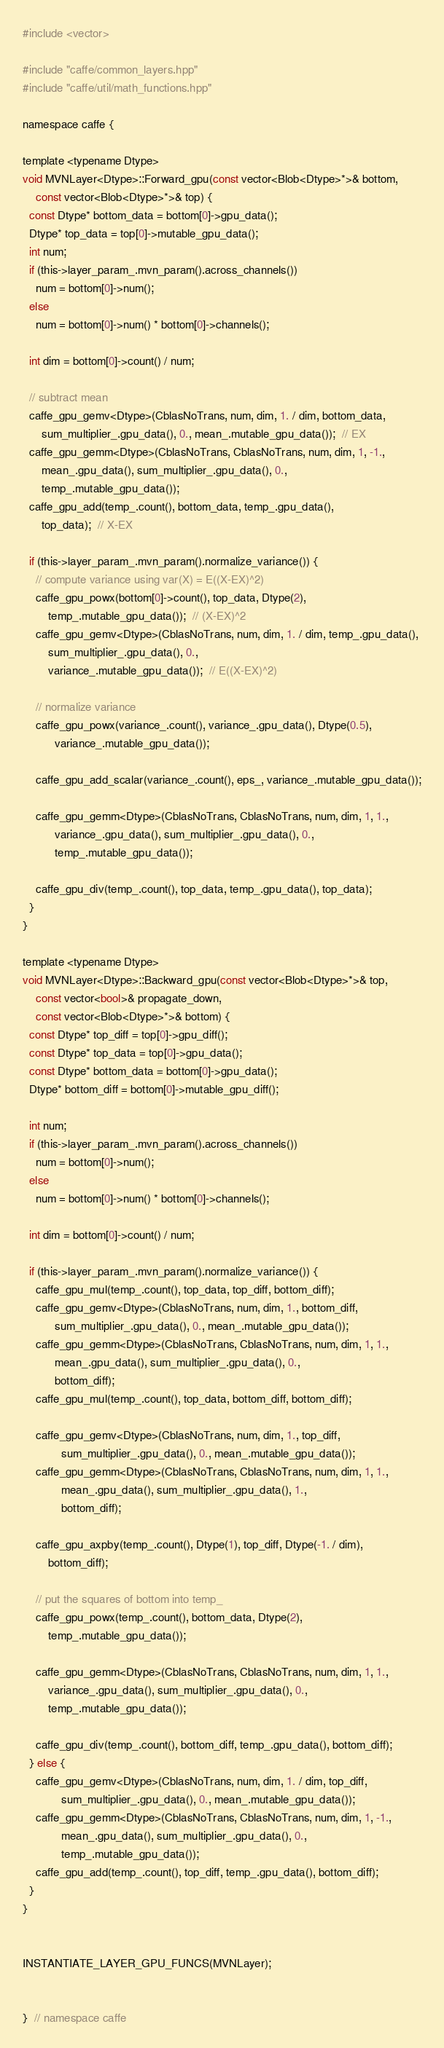Convert code to text. <code><loc_0><loc_0><loc_500><loc_500><_Cuda_>#include <vector>

#include "caffe/common_layers.hpp"
#include "caffe/util/math_functions.hpp"

namespace caffe {

template <typename Dtype>
void MVNLayer<Dtype>::Forward_gpu(const vector<Blob<Dtype>*>& bottom,
    const vector<Blob<Dtype>*>& top) {
  const Dtype* bottom_data = bottom[0]->gpu_data();
  Dtype* top_data = top[0]->mutable_gpu_data();
  int num;
  if (this->layer_param_.mvn_param().across_channels())
    num = bottom[0]->num();
  else
    num = bottom[0]->num() * bottom[0]->channels();

  int dim = bottom[0]->count() / num;

  // subtract mean
  caffe_gpu_gemv<Dtype>(CblasNoTrans, num, dim, 1. / dim, bottom_data,
      sum_multiplier_.gpu_data(), 0., mean_.mutable_gpu_data());  // EX
  caffe_gpu_gemm<Dtype>(CblasNoTrans, CblasNoTrans, num, dim, 1, -1.,
      mean_.gpu_data(), sum_multiplier_.gpu_data(), 0.,
      temp_.mutable_gpu_data());
  caffe_gpu_add(temp_.count(), bottom_data, temp_.gpu_data(),
      top_data);  // X-EX

  if (this->layer_param_.mvn_param().normalize_variance()) {
    // compute variance using var(X) = E((X-EX)^2)
    caffe_gpu_powx(bottom[0]->count(), top_data, Dtype(2),
        temp_.mutable_gpu_data());  // (X-EX)^2
    caffe_gpu_gemv<Dtype>(CblasNoTrans, num, dim, 1. / dim, temp_.gpu_data(),
        sum_multiplier_.gpu_data(), 0.,
        variance_.mutable_gpu_data());  // E((X-EX)^2)

    // normalize variance
    caffe_gpu_powx(variance_.count(), variance_.gpu_data(), Dtype(0.5),
          variance_.mutable_gpu_data());

    caffe_gpu_add_scalar(variance_.count(), eps_, variance_.mutable_gpu_data());

    caffe_gpu_gemm<Dtype>(CblasNoTrans, CblasNoTrans, num, dim, 1, 1.,
          variance_.gpu_data(), sum_multiplier_.gpu_data(), 0.,
          temp_.mutable_gpu_data());

    caffe_gpu_div(temp_.count(), top_data, temp_.gpu_data(), top_data);
  }
}

template <typename Dtype>
void MVNLayer<Dtype>::Backward_gpu(const vector<Blob<Dtype>*>& top,
    const vector<bool>& propagate_down,
    const vector<Blob<Dtype>*>& bottom) {
  const Dtype* top_diff = top[0]->gpu_diff();
  const Dtype* top_data = top[0]->gpu_data();
  const Dtype* bottom_data = bottom[0]->gpu_data();
  Dtype* bottom_diff = bottom[0]->mutable_gpu_diff();

  int num;
  if (this->layer_param_.mvn_param().across_channels())
    num = bottom[0]->num();
  else
    num = bottom[0]->num() * bottom[0]->channels();

  int dim = bottom[0]->count() / num;

  if (this->layer_param_.mvn_param().normalize_variance()) {
    caffe_gpu_mul(temp_.count(), top_data, top_diff, bottom_diff);
    caffe_gpu_gemv<Dtype>(CblasNoTrans, num, dim, 1., bottom_diff,
          sum_multiplier_.gpu_data(), 0., mean_.mutable_gpu_data());
    caffe_gpu_gemm<Dtype>(CblasNoTrans, CblasNoTrans, num, dim, 1, 1.,
          mean_.gpu_data(), sum_multiplier_.gpu_data(), 0.,
          bottom_diff);
    caffe_gpu_mul(temp_.count(), top_data, bottom_diff, bottom_diff);

    caffe_gpu_gemv<Dtype>(CblasNoTrans, num, dim, 1., top_diff,
            sum_multiplier_.gpu_data(), 0., mean_.mutable_gpu_data());
    caffe_gpu_gemm<Dtype>(CblasNoTrans, CblasNoTrans, num, dim, 1, 1.,
            mean_.gpu_data(), sum_multiplier_.gpu_data(), 1.,
            bottom_diff);

    caffe_gpu_axpby(temp_.count(), Dtype(1), top_diff, Dtype(-1. / dim),
        bottom_diff);

    // put the squares of bottom into temp_
    caffe_gpu_powx(temp_.count(), bottom_data, Dtype(2),
        temp_.mutable_gpu_data());

    caffe_gpu_gemm<Dtype>(CblasNoTrans, CblasNoTrans, num, dim, 1, 1.,
        variance_.gpu_data(), sum_multiplier_.gpu_data(), 0.,
        temp_.mutable_gpu_data());

    caffe_gpu_div(temp_.count(), bottom_diff, temp_.gpu_data(), bottom_diff);
  } else {
    caffe_gpu_gemv<Dtype>(CblasNoTrans, num, dim, 1. / dim, top_diff,
            sum_multiplier_.gpu_data(), 0., mean_.mutable_gpu_data());
    caffe_gpu_gemm<Dtype>(CblasNoTrans, CblasNoTrans, num, dim, 1, -1.,
            mean_.gpu_data(), sum_multiplier_.gpu_data(), 0.,
            temp_.mutable_gpu_data());
    caffe_gpu_add(temp_.count(), top_diff, temp_.gpu_data(), bottom_diff);
  }
}


INSTANTIATE_LAYER_GPU_FUNCS(MVNLayer);


}  // namespace caffe
</code> 